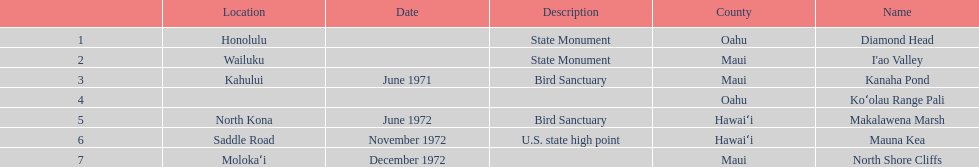Is kanaha pond a state monument or a bird sanctuary? Bird Sanctuary. 